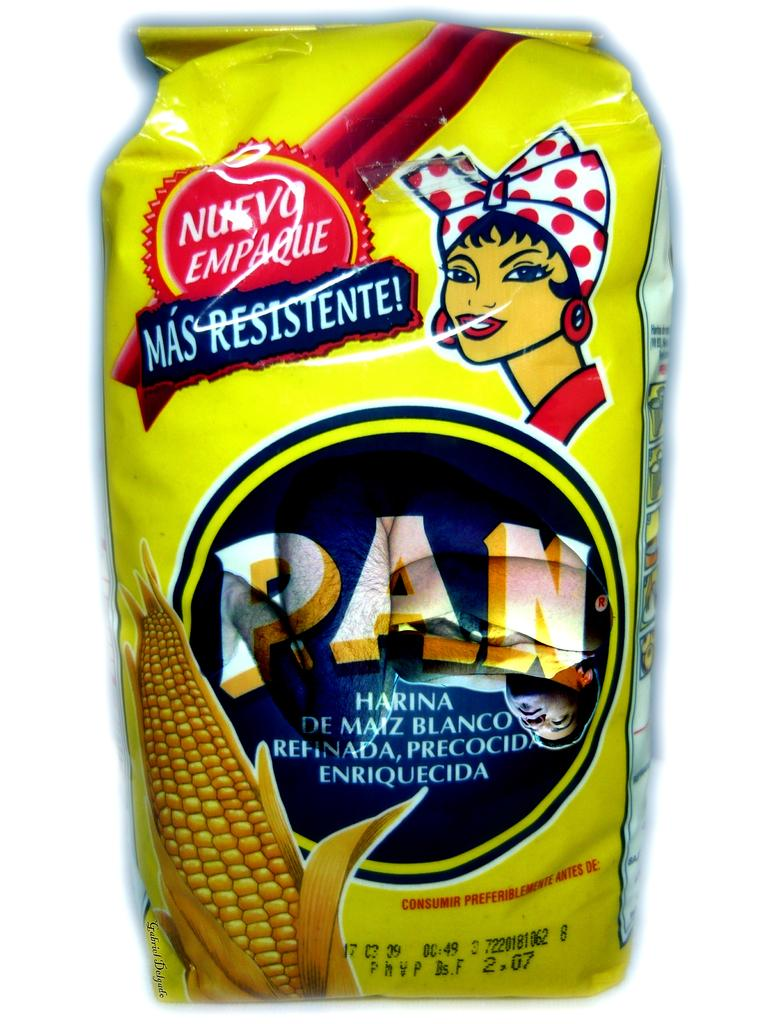What is the main subject of the image? The main subject of the image is a packet. What is depicted on the packet? The packet has a picture of corn. Are there any people shown on the packet? Yes, there are people depicted on the packet. Is there any text written on the packet? Yes, there is text written on the packet. What type of apparel are the people wearing in the image? There are no people wearing apparel in the image, as the people depicted are on the packet, not in the image itself. 